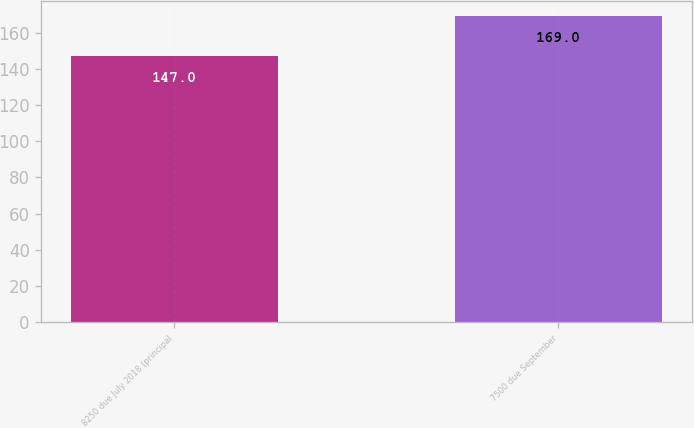Convert chart to OTSL. <chart><loc_0><loc_0><loc_500><loc_500><bar_chart><fcel>8250 due July 2018 (principal<fcel>7500 due September<nl><fcel>147<fcel>169<nl></chart> 